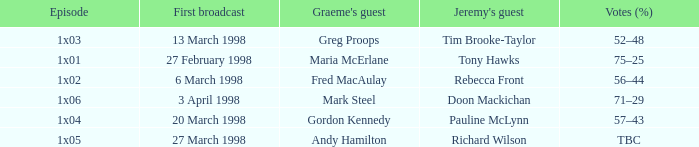What is Votes (%), when Episode is "1x03"? 52–48. Can you parse all the data within this table? {'header': ['Episode', 'First broadcast', "Graeme's guest", "Jeremy's guest", 'Votes (%)'], 'rows': [['1x03', '13 March 1998', 'Greg Proops', 'Tim Brooke-Taylor', '52–48'], ['1x01', '27 February 1998', 'Maria McErlane', 'Tony Hawks', '75–25'], ['1x02', '6 March 1998', 'Fred MacAulay', 'Rebecca Front', '56–44'], ['1x06', '3 April 1998', 'Mark Steel', 'Doon Mackichan', '71–29'], ['1x04', '20 March 1998', 'Gordon Kennedy', 'Pauline McLynn', '57–43'], ['1x05', '27 March 1998', 'Andy Hamilton', 'Richard Wilson', 'TBC']]} 